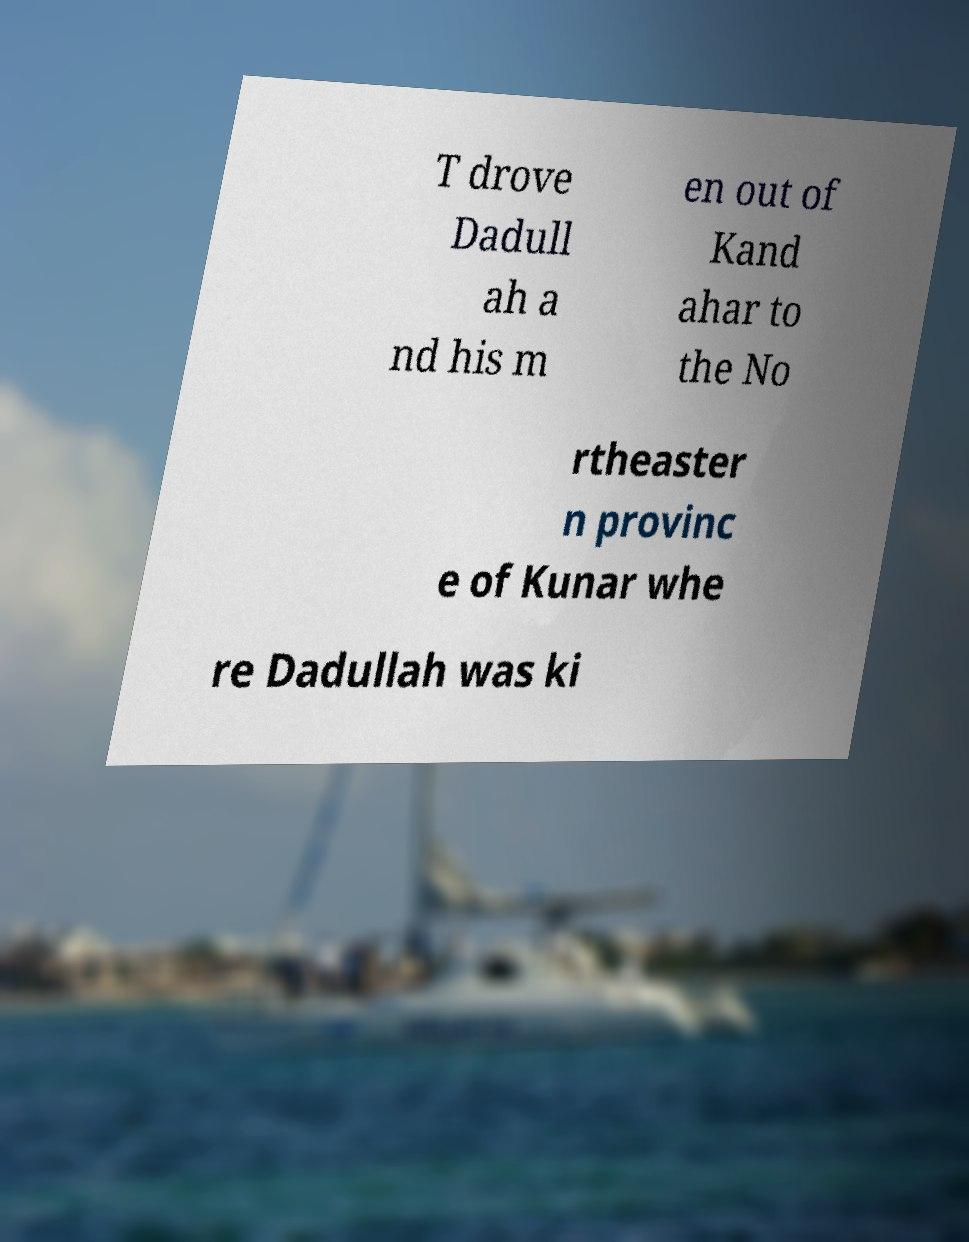Please read and relay the text visible in this image. What does it say? T drove Dadull ah a nd his m en out of Kand ahar to the No rtheaster n provinc e of Kunar whe re Dadullah was ki 